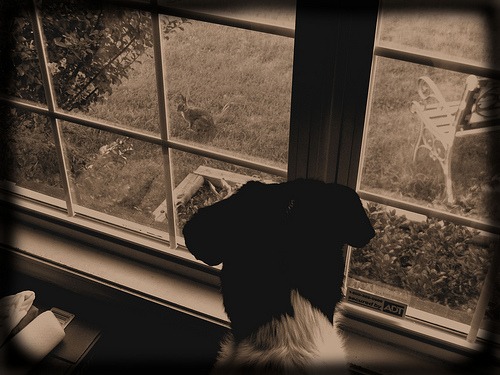<image>
Is there a window in front of the dog? Yes. The window is positioned in front of the dog, appearing closer to the camera viewpoint. Is there a rabbit above the dog? No. The rabbit is not positioned above the dog. The vertical arrangement shows a different relationship. 